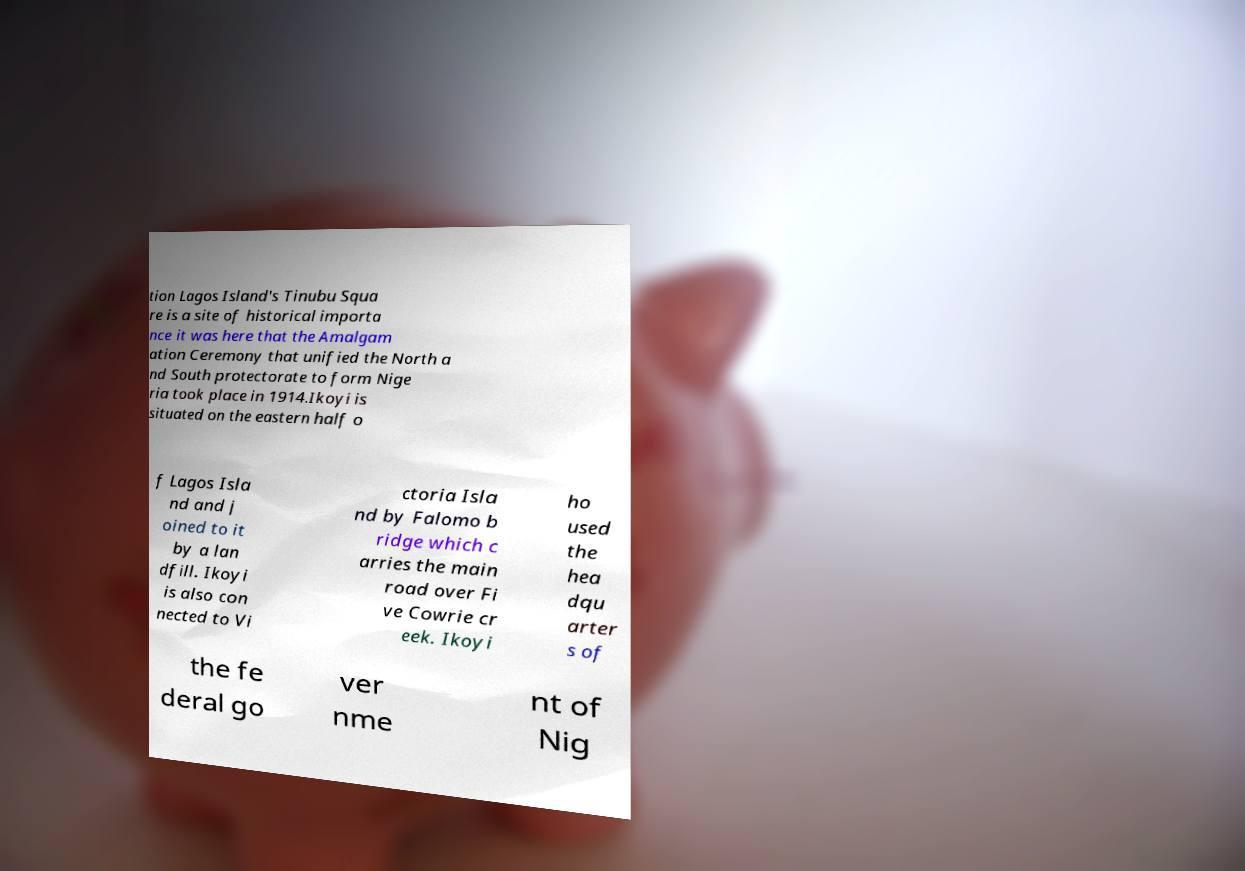I need the written content from this picture converted into text. Can you do that? tion Lagos Island's Tinubu Squa re is a site of historical importa nce it was here that the Amalgam ation Ceremony that unified the North a nd South protectorate to form Nige ria took place in 1914.Ikoyi is situated on the eastern half o f Lagos Isla nd and j oined to it by a lan dfill. Ikoyi is also con nected to Vi ctoria Isla nd by Falomo b ridge which c arries the main road over Fi ve Cowrie cr eek. Ikoyi ho used the hea dqu arter s of the fe deral go ver nme nt of Nig 